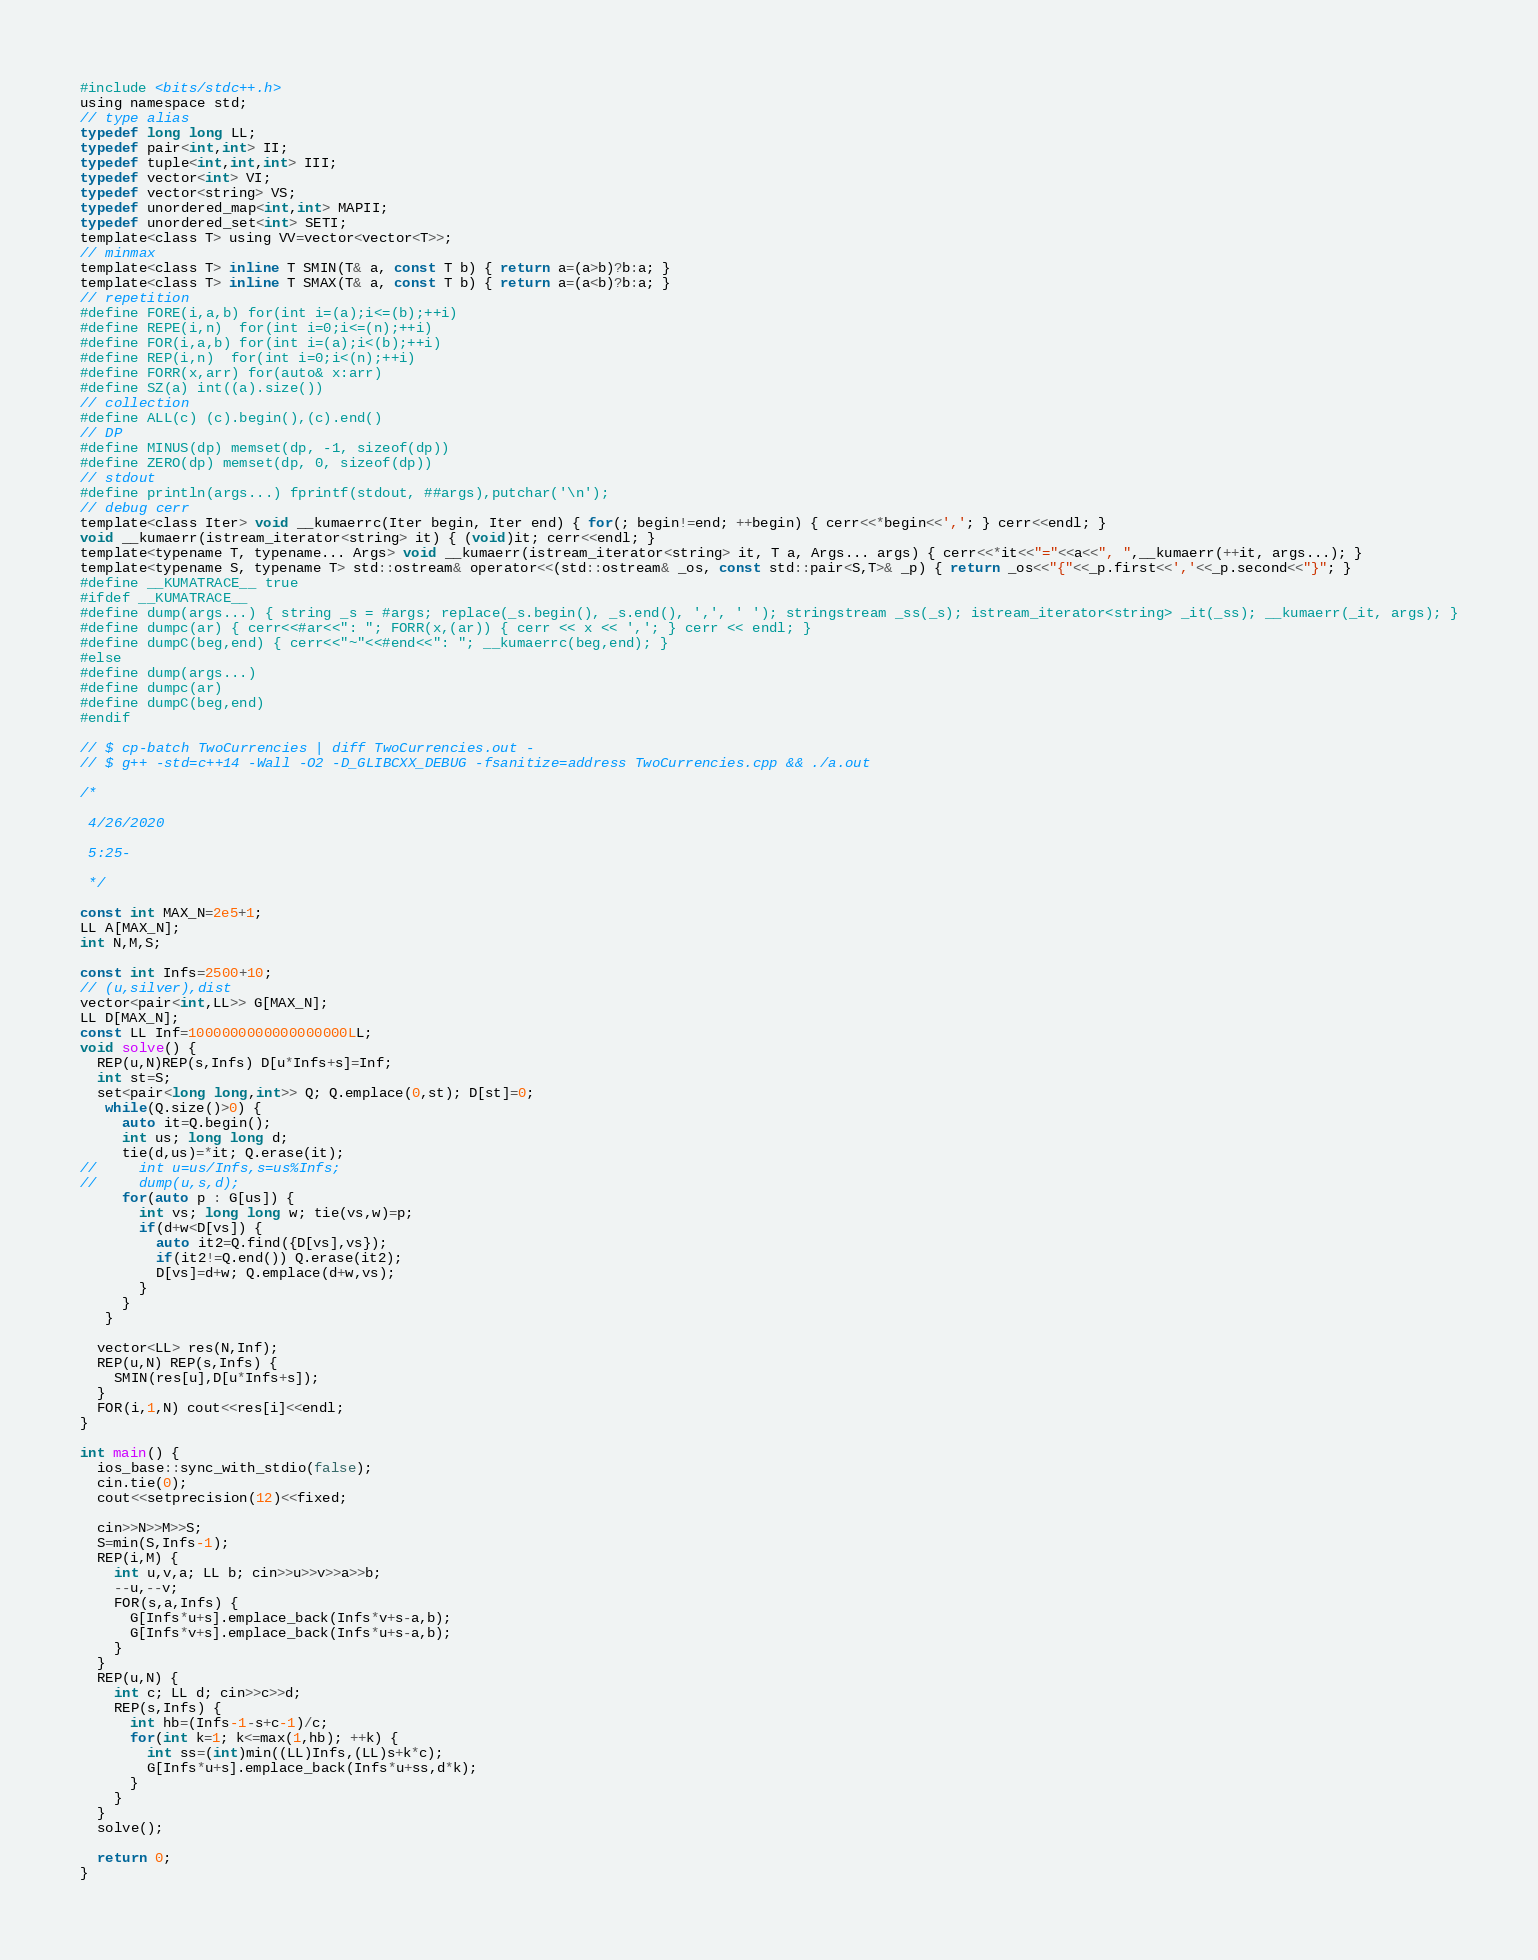Convert code to text. <code><loc_0><loc_0><loc_500><loc_500><_C_>#include <bits/stdc++.h>
using namespace std;
// type alias
typedef long long LL;
typedef pair<int,int> II;
typedef tuple<int,int,int> III;
typedef vector<int> VI;
typedef vector<string> VS;
typedef unordered_map<int,int> MAPII;
typedef unordered_set<int> SETI;
template<class T> using VV=vector<vector<T>>;
// minmax
template<class T> inline T SMIN(T& a, const T b) { return a=(a>b)?b:a; }
template<class T> inline T SMAX(T& a, const T b) { return a=(a<b)?b:a; }
// repetition
#define FORE(i,a,b) for(int i=(a);i<=(b);++i)
#define REPE(i,n)  for(int i=0;i<=(n);++i)
#define FOR(i,a,b) for(int i=(a);i<(b);++i)
#define REP(i,n)  for(int i=0;i<(n);++i)
#define FORR(x,arr) for(auto& x:arr)
#define SZ(a) int((a).size())
// collection
#define ALL(c) (c).begin(),(c).end()
// DP
#define MINUS(dp) memset(dp, -1, sizeof(dp))
#define ZERO(dp) memset(dp, 0, sizeof(dp))
// stdout
#define println(args...) fprintf(stdout, ##args),putchar('\n');
// debug cerr
template<class Iter> void __kumaerrc(Iter begin, Iter end) { for(; begin!=end; ++begin) { cerr<<*begin<<','; } cerr<<endl; }
void __kumaerr(istream_iterator<string> it) { (void)it; cerr<<endl; }
template<typename T, typename... Args> void __kumaerr(istream_iterator<string> it, T a, Args... args) { cerr<<*it<<"="<<a<<", ",__kumaerr(++it, args...); }
template<typename S, typename T> std::ostream& operator<<(std::ostream& _os, const std::pair<S,T>& _p) { return _os<<"{"<<_p.first<<','<<_p.second<<"}"; }
#define __KUMATRACE__ true
#ifdef __KUMATRACE__
#define dump(args...) { string _s = #args; replace(_s.begin(), _s.end(), ',', ' '); stringstream _ss(_s); istream_iterator<string> _it(_ss); __kumaerr(_it, args); }
#define dumpc(ar) { cerr<<#ar<<": "; FORR(x,(ar)) { cerr << x << ','; } cerr << endl; }
#define dumpC(beg,end) { cerr<<"~"<<#end<<": "; __kumaerrc(beg,end); }
#else
#define dump(args...)
#define dumpc(ar)
#define dumpC(beg,end)
#endif

// $ cp-batch TwoCurrencies | diff TwoCurrencies.out -
// $ g++ -std=c++14 -Wall -O2 -D_GLIBCXX_DEBUG -fsanitize=address TwoCurrencies.cpp && ./a.out

/*
 
 4/26/2020
 
 5:25-
 
 */

const int MAX_N=2e5+1;
LL A[MAX_N];
int N,M,S;

const int Infs=2500+10;
// (u,silver),dist
vector<pair<int,LL>> G[MAX_N];
LL D[MAX_N];
const LL Inf=1000000000000000000LL;
void solve() {
  REP(u,N)REP(s,Infs) D[u*Infs+s]=Inf;
  int st=S;
  set<pair<long long,int>> Q; Q.emplace(0,st); D[st]=0;
   while(Q.size()>0) {
     auto it=Q.begin();
     int us; long long d;
     tie(d,us)=*it; Q.erase(it);
//     int u=us/Infs,s=us%Infs;
//     dump(u,s,d);
     for(auto p : G[us]) {
       int vs; long long w; tie(vs,w)=p;
       if(d+w<D[vs]) {
         auto it2=Q.find({D[vs],vs});
         if(it2!=Q.end()) Q.erase(it2);
         D[vs]=d+w; Q.emplace(d+w,vs);
       }
     }
   }
  
  vector<LL> res(N,Inf);
  REP(u,N) REP(s,Infs) {
    SMIN(res[u],D[u*Infs+s]);
  }
  FOR(i,1,N) cout<<res[i]<<endl;
}

int main() {
  ios_base::sync_with_stdio(false);
  cin.tie(0);
  cout<<setprecision(12)<<fixed;
  
  cin>>N>>M>>S;
  S=min(S,Infs-1);
  REP(i,M) {
    int u,v,a; LL b; cin>>u>>v>>a>>b;
    --u,--v;
    FOR(s,a,Infs) {
      G[Infs*u+s].emplace_back(Infs*v+s-a,b);
      G[Infs*v+s].emplace_back(Infs*u+s-a,b);
    }
  }
  REP(u,N) {
    int c; LL d; cin>>c>>d;
    REP(s,Infs) {
      int hb=(Infs-1-s+c-1)/c;
      for(int k=1; k<=max(1,hb); ++k) {
        int ss=(int)min((LL)Infs,(LL)s+k*c);
        G[Infs*u+s].emplace_back(Infs*u+ss,d*k);
      }
    }
  }
  solve();
  
  return 0;
}
</code> 